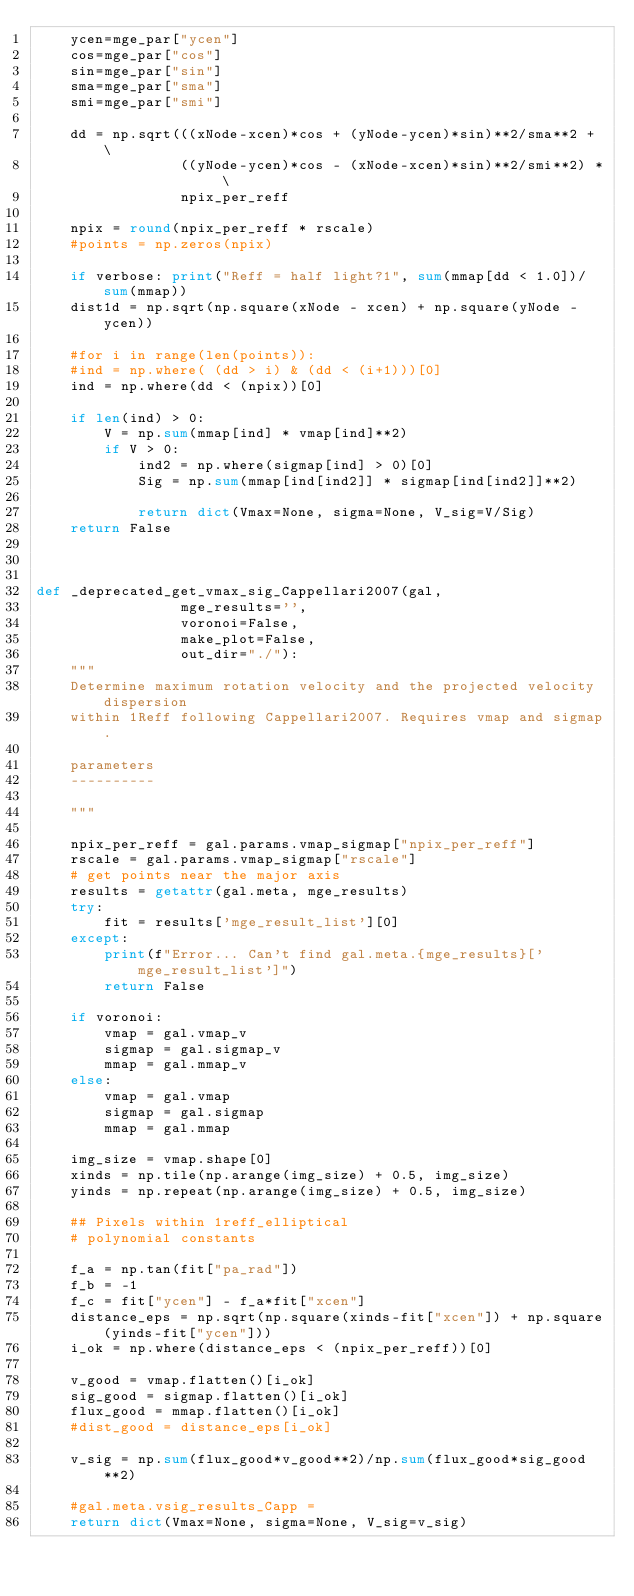Convert code to text. <code><loc_0><loc_0><loc_500><loc_500><_Python_>    ycen=mge_par["ycen"]
    cos=mge_par["cos"]
    sin=mge_par["sin"]
    sma=mge_par["sma"]
    smi=mge_par["smi"]

    dd = np.sqrt(((xNode-xcen)*cos + (yNode-ycen)*sin)**2/sma**2 + \
                 ((yNode-ycen)*cos - (xNode-xcen)*sin)**2/smi**2) * \
                 npix_per_reff

    npix = round(npix_per_reff * rscale)
    #points = np.zeros(npix)

    if verbose: print("Reff = half light?1", sum(mmap[dd < 1.0])/ sum(mmap))
    dist1d = np.sqrt(np.square(xNode - xcen) + np.square(yNode - ycen))

    #for i in range(len(points)):
    #ind = np.where( (dd > i) & (dd < (i+1)))[0]
    ind = np.where(dd < (npix))[0]

    if len(ind) > 0:
        V = np.sum(mmap[ind] * vmap[ind]**2)
        if V > 0:
            ind2 = np.where(sigmap[ind] > 0)[0]
            Sig = np.sum(mmap[ind[ind2]] * sigmap[ind[ind2]]**2)

            return dict(Vmax=None, sigma=None, V_sig=V/Sig)
    return False



def _deprecated_get_vmax_sig_Cappellari2007(gal,
                 mge_results='',
                 voronoi=False,
                 make_plot=False,
                 out_dir="./"):
    """
    Determine maximum rotation velocity and the projected velocity dispersion
    within 1Reff following Cappellari2007. Requires vmap and sigmap.

    parameters
    ----------

    """

    npix_per_reff = gal.params.vmap_sigmap["npix_per_reff"]
    rscale = gal.params.vmap_sigmap["rscale"]
    # get points near the major axis
    results = getattr(gal.meta, mge_results)
    try:
        fit = results['mge_result_list'][0]
    except:
        print(f"Error... Can't find gal.meta.{mge_results}['mge_result_list']")
        return False

    if voronoi:
        vmap = gal.vmap_v
        sigmap = gal.sigmap_v
        mmap = gal.mmap_v
    else:
        vmap = gal.vmap
        sigmap = gal.sigmap
        mmap = gal.mmap

    img_size = vmap.shape[0]
    xinds = np.tile(np.arange(img_size) + 0.5, img_size)
    yinds = np.repeat(np.arange(img_size) + 0.5, img_size)
        
    ## Pixels within 1reff_elliptical
    # polynomial constants
    
    f_a = np.tan(fit["pa_rad"])
    f_b = -1
    f_c = fit["ycen"] - f_a*fit["xcen"]
    distance_eps = np.sqrt(np.square(xinds-fit["xcen"]) + np.square(yinds-fit["ycen"]))
    i_ok = np.where(distance_eps < (npix_per_reff))[0]

    v_good = vmap.flatten()[i_ok]
    sig_good = sigmap.flatten()[i_ok]
    flux_good = mmap.flatten()[i_ok]
    #dist_good = distance_eps[i_ok]

    v_sig = np.sum(flux_good*v_good**2)/np.sum(flux_good*sig_good**2)

    #gal.meta.vsig_results_Capp = 
    return dict(Vmax=None, sigma=None, V_sig=v_sig)
</code> 